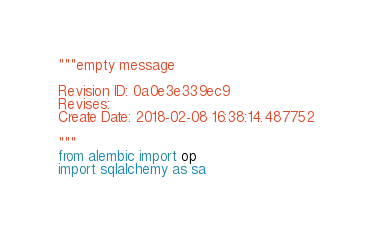Convert code to text. <code><loc_0><loc_0><loc_500><loc_500><_Python_>"""empty message

Revision ID: 0a0e3e339ec9
Revises: 
Create Date: 2018-02-08 16:38:14.487752

"""
from alembic import op
import sqlalchemy as sa

</code> 